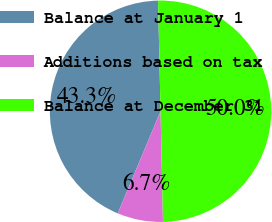<chart> <loc_0><loc_0><loc_500><loc_500><pie_chart><fcel>Balance at January 1<fcel>Additions based on tax<fcel>Balance at December 31<nl><fcel>43.33%<fcel>6.67%<fcel>50.0%<nl></chart> 